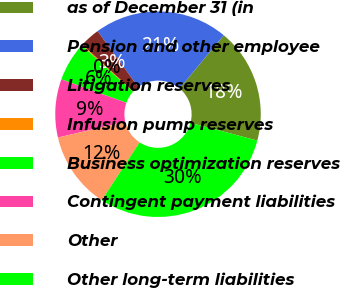<chart> <loc_0><loc_0><loc_500><loc_500><pie_chart><fcel>as of December 31 (in<fcel>Pension and other employee<fcel>Litigation reserves<fcel>Infusion pump reserves<fcel>Business optimization reserves<fcel>Contingent payment liabilities<fcel>Other<fcel>Other long-term liabilities<nl><fcel>18.07%<fcel>21.07%<fcel>3.16%<fcel>0.17%<fcel>6.15%<fcel>9.15%<fcel>12.14%<fcel>30.09%<nl></chart> 